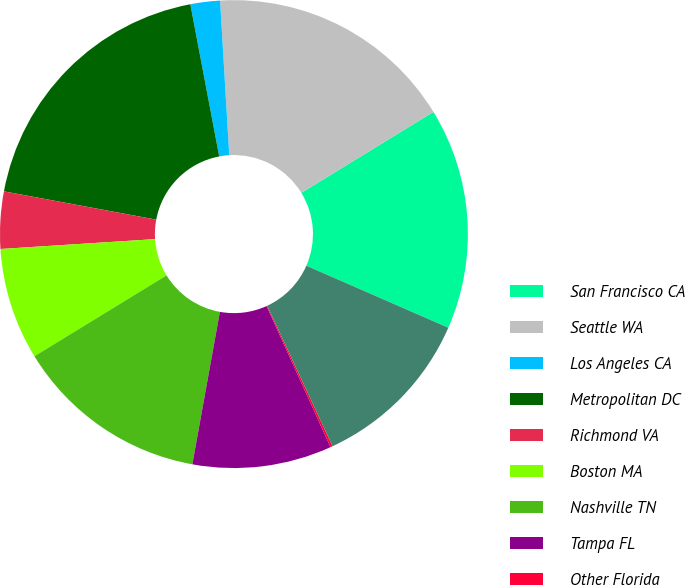Convert chart. <chart><loc_0><loc_0><loc_500><loc_500><pie_chart><fcel>San Francisco CA<fcel>Seattle WA<fcel>Los Angeles CA<fcel>Metropolitan DC<fcel>Richmond VA<fcel>Boston MA<fcel>Nashville TN<fcel>Tampa FL<fcel>Other Florida<fcel>Dallas TX<nl><fcel>15.3%<fcel>17.2%<fcel>2.04%<fcel>19.09%<fcel>3.94%<fcel>7.73%<fcel>13.41%<fcel>9.62%<fcel>0.15%<fcel>11.52%<nl></chart> 